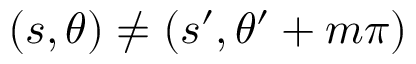Convert formula to latex. <formula><loc_0><loc_0><loc_500><loc_500>( s , \theta ) \neq ( s ^ { \prime } , \theta ^ { \prime } + m \pi )</formula> 